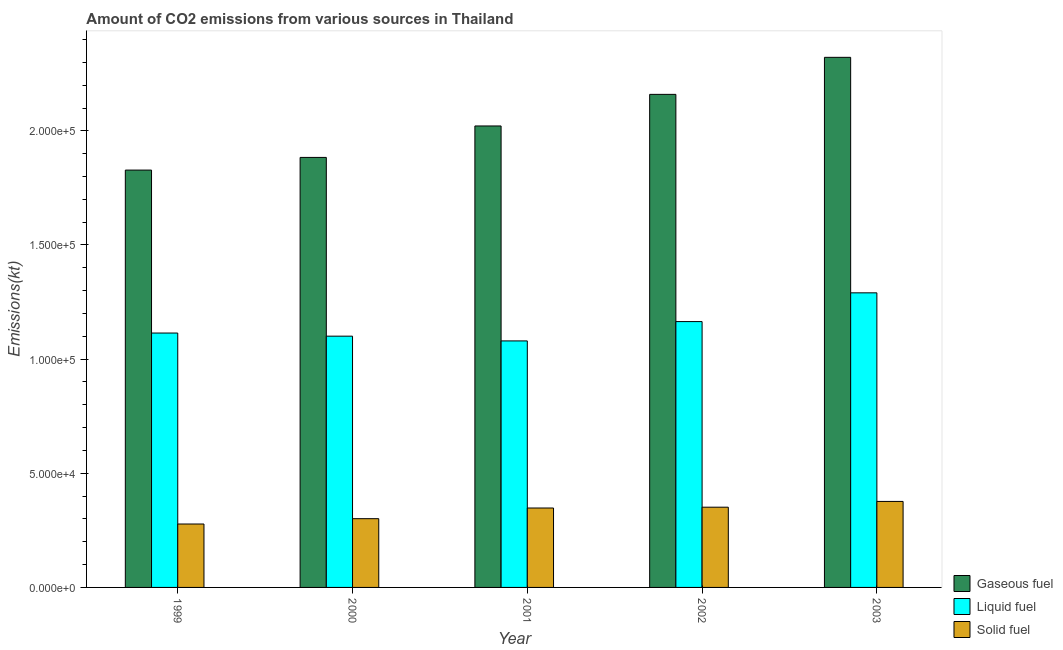Are the number of bars per tick equal to the number of legend labels?
Offer a terse response. Yes. How many bars are there on the 2nd tick from the right?
Keep it short and to the point. 3. What is the amount of co2 emissions from solid fuel in 2000?
Keep it short and to the point. 3.01e+04. Across all years, what is the maximum amount of co2 emissions from gaseous fuel?
Give a very brief answer. 2.32e+05. Across all years, what is the minimum amount of co2 emissions from liquid fuel?
Provide a short and direct response. 1.08e+05. In which year was the amount of co2 emissions from liquid fuel maximum?
Your response must be concise. 2003. What is the total amount of co2 emissions from solid fuel in the graph?
Make the answer very short. 1.65e+05. What is the difference between the amount of co2 emissions from gaseous fuel in 2000 and that in 2002?
Provide a short and direct response. -2.76e+04. What is the difference between the amount of co2 emissions from gaseous fuel in 2000 and the amount of co2 emissions from liquid fuel in 2001?
Give a very brief answer. -1.38e+04. What is the average amount of co2 emissions from gaseous fuel per year?
Offer a terse response. 2.04e+05. What is the ratio of the amount of co2 emissions from gaseous fuel in 2001 to that in 2002?
Your response must be concise. 0.94. Is the amount of co2 emissions from gaseous fuel in 2000 less than that in 2003?
Your answer should be very brief. Yes. What is the difference between the highest and the second highest amount of co2 emissions from gaseous fuel?
Give a very brief answer. 1.62e+04. What is the difference between the highest and the lowest amount of co2 emissions from gaseous fuel?
Your response must be concise. 4.94e+04. What does the 3rd bar from the left in 2000 represents?
Offer a terse response. Solid fuel. What does the 1st bar from the right in 2003 represents?
Provide a short and direct response. Solid fuel. Is it the case that in every year, the sum of the amount of co2 emissions from gaseous fuel and amount of co2 emissions from liquid fuel is greater than the amount of co2 emissions from solid fuel?
Keep it short and to the point. Yes. How many bars are there?
Offer a very short reply. 15. Does the graph contain any zero values?
Provide a short and direct response. No. Does the graph contain grids?
Give a very brief answer. No. Where does the legend appear in the graph?
Your answer should be compact. Bottom right. How many legend labels are there?
Provide a succinct answer. 3. What is the title of the graph?
Offer a terse response. Amount of CO2 emissions from various sources in Thailand. Does "Ages 20-50" appear as one of the legend labels in the graph?
Provide a succinct answer. No. What is the label or title of the Y-axis?
Give a very brief answer. Emissions(kt). What is the Emissions(kt) of Gaseous fuel in 1999?
Give a very brief answer. 1.83e+05. What is the Emissions(kt) in Liquid fuel in 1999?
Your answer should be compact. 1.11e+05. What is the Emissions(kt) in Solid fuel in 1999?
Provide a short and direct response. 2.78e+04. What is the Emissions(kt) in Gaseous fuel in 2000?
Provide a succinct answer. 1.88e+05. What is the Emissions(kt) in Liquid fuel in 2000?
Your answer should be very brief. 1.10e+05. What is the Emissions(kt) of Solid fuel in 2000?
Offer a terse response. 3.01e+04. What is the Emissions(kt) of Gaseous fuel in 2001?
Ensure brevity in your answer.  2.02e+05. What is the Emissions(kt) in Liquid fuel in 2001?
Give a very brief answer. 1.08e+05. What is the Emissions(kt) in Solid fuel in 2001?
Your answer should be compact. 3.48e+04. What is the Emissions(kt) of Gaseous fuel in 2002?
Provide a short and direct response. 2.16e+05. What is the Emissions(kt) in Liquid fuel in 2002?
Offer a terse response. 1.16e+05. What is the Emissions(kt) of Solid fuel in 2002?
Provide a succinct answer. 3.51e+04. What is the Emissions(kt) in Gaseous fuel in 2003?
Provide a short and direct response. 2.32e+05. What is the Emissions(kt) in Liquid fuel in 2003?
Provide a succinct answer. 1.29e+05. What is the Emissions(kt) of Solid fuel in 2003?
Your answer should be very brief. 3.77e+04. Across all years, what is the maximum Emissions(kt) of Gaseous fuel?
Make the answer very short. 2.32e+05. Across all years, what is the maximum Emissions(kt) of Liquid fuel?
Give a very brief answer. 1.29e+05. Across all years, what is the maximum Emissions(kt) of Solid fuel?
Your answer should be compact. 3.77e+04. Across all years, what is the minimum Emissions(kt) of Gaseous fuel?
Your response must be concise. 1.83e+05. Across all years, what is the minimum Emissions(kt) in Liquid fuel?
Your answer should be compact. 1.08e+05. Across all years, what is the minimum Emissions(kt) of Solid fuel?
Your answer should be very brief. 2.78e+04. What is the total Emissions(kt) of Gaseous fuel in the graph?
Your answer should be very brief. 1.02e+06. What is the total Emissions(kt) of Liquid fuel in the graph?
Ensure brevity in your answer.  5.75e+05. What is the total Emissions(kt) in Solid fuel in the graph?
Provide a short and direct response. 1.65e+05. What is the difference between the Emissions(kt) of Gaseous fuel in 1999 and that in 2000?
Your answer should be compact. -5544.5. What is the difference between the Emissions(kt) of Liquid fuel in 1999 and that in 2000?
Your response must be concise. 1371.46. What is the difference between the Emissions(kt) in Solid fuel in 1999 and that in 2000?
Provide a succinct answer. -2328.55. What is the difference between the Emissions(kt) in Gaseous fuel in 1999 and that in 2001?
Your response must be concise. -1.93e+04. What is the difference between the Emissions(kt) in Liquid fuel in 1999 and that in 2001?
Provide a succinct answer. 3446.98. What is the difference between the Emissions(kt) in Solid fuel in 1999 and that in 2001?
Provide a short and direct response. -7007.64. What is the difference between the Emissions(kt) of Gaseous fuel in 1999 and that in 2002?
Offer a terse response. -3.32e+04. What is the difference between the Emissions(kt) in Liquid fuel in 1999 and that in 2002?
Offer a very short reply. -5016.46. What is the difference between the Emissions(kt) in Solid fuel in 1999 and that in 2002?
Make the answer very short. -7363.34. What is the difference between the Emissions(kt) in Gaseous fuel in 1999 and that in 2003?
Make the answer very short. -4.94e+04. What is the difference between the Emissions(kt) in Liquid fuel in 1999 and that in 2003?
Provide a succinct answer. -1.76e+04. What is the difference between the Emissions(kt) of Solid fuel in 1999 and that in 2003?
Give a very brief answer. -9886.23. What is the difference between the Emissions(kt) of Gaseous fuel in 2000 and that in 2001?
Provide a short and direct response. -1.38e+04. What is the difference between the Emissions(kt) in Liquid fuel in 2000 and that in 2001?
Your response must be concise. 2075.52. What is the difference between the Emissions(kt) of Solid fuel in 2000 and that in 2001?
Make the answer very short. -4679.09. What is the difference between the Emissions(kt) of Gaseous fuel in 2000 and that in 2002?
Make the answer very short. -2.76e+04. What is the difference between the Emissions(kt) in Liquid fuel in 2000 and that in 2002?
Offer a very short reply. -6387.91. What is the difference between the Emissions(kt) in Solid fuel in 2000 and that in 2002?
Ensure brevity in your answer.  -5034.79. What is the difference between the Emissions(kt) in Gaseous fuel in 2000 and that in 2003?
Your answer should be very brief. -4.38e+04. What is the difference between the Emissions(kt) in Liquid fuel in 2000 and that in 2003?
Make the answer very short. -1.90e+04. What is the difference between the Emissions(kt) of Solid fuel in 2000 and that in 2003?
Give a very brief answer. -7557.69. What is the difference between the Emissions(kt) of Gaseous fuel in 2001 and that in 2002?
Your answer should be compact. -1.38e+04. What is the difference between the Emissions(kt) in Liquid fuel in 2001 and that in 2002?
Offer a terse response. -8463.44. What is the difference between the Emissions(kt) in Solid fuel in 2001 and that in 2002?
Offer a very short reply. -355.7. What is the difference between the Emissions(kt) in Gaseous fuel in 2001 and that in 2003?
Provide a short and direct response. -3.01e+04. What is the difference between the Emissions(kt) in Liquid fuel in 2001 and that in 2003?
Your answer should be very brief. -2.11e+04. What is the difference between the Emissions(kt) in Solid fuel in 2001 and that in 2003?
Keep it short and to the point. -2878.59. What is the difference between the Emissions(kt) of Gaseous fuel in 2002 and that in 2003?
Ensure brevity in your answer.  -1.62e+04. What is the difference between the Emissions(kt) of Liquid fuel in 2002 and that in 2003?
Make the answer very short. -1.26e+04. What is the difference between the Emissions(kt) in Solid fuel in 2002 and that in 2003?
Offer a terse response. -2522.9. What is the difference between the Emissions(kt) in Gaseous fuel in 1999 and the Emissions(kt) in Liquid fuel in 2000?
Make the answer very short. 7.28e+04. What is the difference between the Emissions(kt) of Gaseous fuel in 1999 and the Emissions(kt) of Solid fuel in 2000?
Your answer should be very brief. 1.53e+05. What is the difference between the Emissions(kt) in Liquid fuel in 1999 and the Emissions(kt) in Solid fuel in 2000?
Keep it short and to the point. 8.13e+04. What is the difference between the Emissions(kt) in Gaseous fuel in 1999 and the Emissions(kt) in Liquid fuel in 2001?
Provide a succinct answer. 7.48e+04. What is the difference between the Emissions(kt) in Gaseous fuel in 1999 and the Emissions(kt) in Solid fuel in 2001?
Provide a short and direct response. 1.48e+05. What is the difference between the Emissions(kt) in Liquid fuel in 1999 and the Emissions(kt) in Solid fuel in 2001?
Provide a succinct answer. 7.66e+04. What is the difference between the Emissions(kt) in Gaseous fuel in 1999 and the Emissions(kt) in Liquid fuel in 2002?
Provide a succinct answer. 6.64e+04. What is the difference between the Emissions(kt) of Gaseous fuel in 1999 and the Emissions(kt) of Solid fuel in 2002?
Provide a short and direct response. 1.48e+05. What is the difference between the Emissions(kt) in Liquid fuel in 1999 and the Emissions(kt) in Solid fuel in 2002?
Your answer should be very brief. 7.63e+04. What is the difference between the Emissions(kt) in Gaseous fuel in 1999 and the Emissions(kt) in Liquid fuel in 2003?
Offer a terse response. 5.38e+04. What is the difference between the Emissions(kt) of Gaseous fuel in 1999 and the Emissions(kt) of Solid fuel in 2003?
Offer a terse response. 1.45e+05. What is the difference between the Emissions(kt) of Liquid fuel in 1999 and the Emissions(kt) of Solid fuel in 2003?
Your answer should be compact. 7.38e+04. What is the difference between the Emissions(kt) in Gaseous fuel in 2000 and the Emissions(kt) in Liquid fuel in 2001?
Your answer should be compact. 8.04e+04. What is the difference between the Emissions(kt) of Gaseous fuel in 2000 and the Emissions(kt) of Solid fuel in 2001?
Your answer should be compact. 1.54e+05. What is the difference between the Emissions(kt) in Liquid fuel in 2000 and the Emissions(kt) in Solid fuel in 2001?
Your response must be concise. 7.53e+04. What is the difference between the Emissions(kt) of Gaseous fuel in 2000 and the Emissions(kt) of Liquid fuel in 2002?
Provide a succinct answer. 7.19e+04. What is the difference between the Emissions(kt) of Gaseous fuel in 2000 and the Emissions(kt) of Solid fuel in 2002?
Your response must be concise. 1.53e+05. What is the difference between the Emissions(kt) in Liquid fuel in 2000 and the Emissions(kt) in Solid fuel in 2002?
Your answer should be very brief. 7.49e+04. What is the difference between the Emissions(kt) of Gaseous fuel in 2000 and the Emissions(kt) of Liquid fuel in 2003?
Keep it short and to the point. 5.93e+04. What is the difference between the Emissions(kt) in Gaseous fuel in 2000 and the Emissions(kt) in Solid fuel in 2003?
Provide a succinct answer. 1.51e+05. What is the difference between the Emissions(kt) of Liquid fuel in 2000 and the Emissions(kt) of Solid fuel in 2003?
Your answer should be very brief. 7.24e+04. What is the difference between the Emissions(kt) of Gaseous fuel in 2001 and the Emissions(kt) of Liquid fuel in 2002?
Your answer should be very brief. 8.57e+04. What is the difference between the Emissions(kt) of Gaseous fuel in 2001 and the Emissions(kt) of Solid fuel in 2002?
Ensure brevity in your answer.  1.67e+05. What is the difference between the Emissions(kt) in Liquid fuel in 2001 and the Emissions(kt) in Solid fuel in 2002?
Your answer should be very brief. 7.28e+04. What is the difference between the Emissions(kt) in Gaseous fuel in 2001 and the Emissions(kt) in Liquid fuel in 2003?
Offer a terse response. 7.31e+04. What is the difference between the Emissions(kt) of Gaseous fuel in 2001 and the Emissions(kt) of Solid fuel in 2003?
Your answer should be very brief. 1.64e+05. What is the difference between the Emissions(kt) in Liquid fuel in 2001 and the Emissions(kt) in Solid fuel in 2003?
Give a very brief answer. 7.03e+04. What is the difference between the Emissions(kt) of Gaseous fuel in 2002 and the Emissions(kt) of Liquid fuel in 2003?
Offer a terse response. 8.69e+04. What is the difference between the Emissions(kt) in Gaseous fuel in 2002 and the Emissions(kt) in Solid fuel in 2003?
Make the answer very short. 1.78e+05. What is the difference between the Emissions(kt) of Liquid fuel in 2002 and the Emissions(kt) of Solid fuel in 2003?
Provide a short and direct response. 7.88e+04. What is the average Emissions(kt) in Gaseous fuel per year?
Ensure brevity in your answer.  2.04e+05. What is the average Emissions(kt) in Liquid fuel per year?
Provide a succinct answer. 1.15e+05. What is the average Emissions(kt) in Solid fuel per year?
Offer a terse response. 3.31e+04. In the year 1999, what is the difference between the Emissions(kt) of Gaseous fuel and Emissions(kt) of Liquid fuel?
Your response must be concise. 7.14e+04. In the year 1999, what is the difference between the Emissions(kt) in Gaseous fuel and Emissions(kt) in Solid fuel?
Your answer should be compact. 1.55e+05. In the year 1999, what is the difference between the Emissions(kt) of Liquid fuel and Emissions(kt) of Solid fuel?
Your answer should be compact. 8.36e+04. In the year 2000, what is the difference between the Emissions(kt) of Gaseous fuel and Emissions(kt) of Liquid fuel?
Your answer should be compact. 7.83e+04. In the year 2000, what is the difference between the Emissions(kt) of Gaseous fuel and Emissions(kt) of Solid fuel?
Offer a very short reply. 1.58e+05. In the year 2000, what is the difference between the Emissions(kt) in Liquid fuel and Emissions(kt) in Solid fuel?
Give a very brief answer. 7.99e+04. In the year 2001, what is the difference between the Emissions(kt) of Gaseous fuel and Emissions(kt) of Liquid fuel?
Ensure brevity in your answer.  9.42e+04. In the year 2001, what is the difference between the Emissions(kt) in Gaseous fuel and Emissions(kt) in Solid fuel?
Provide a succinct answer. 1.67e+05. In the year 2001, what is the difference between the Emissions(kt) of Liquid fuel and Emissions(kt) of Solid fuel?
Ensure brevity in your answer.  7.32e+04. In the year 2002, what is the difference between the Emissions(kt) of Gaseous fuel and Emissions(kt) of Liquid fuel?
Your response must be concise. 9.95e+04. In the year 2002, what is the difference between the Emissions(kt) in Gaseous fuel and Emissions(kt) in Solid fuel?
Provide a succinct answer. 1.81e+05. In the year 2002, what is the difference between the Emissions(kt) of Liquid fuel and Emissions(kt) of Solid fuel?
Provide a succinct answer. 8.13e+04. In the year 2003, what is the difference between the Emissions(kt) of Gaseous fuel and Emissions(kt) of Liquid fuel?
Provide a short and direct response. 1.03e+05. In the year 2003, what is the difference between the Emissions(kt) in Gaseous fuel and Emissions(kt) in Solid fuel?
Offer a very short reply. 1.95e+05. In the year 2003, what is the difference between the Emissions(kt) in Liquid fuel and Emissions(kt) in Solid fuel?
Give a very brief answer. 9.14e+04. What is the ratio of the Emissions(kt) in Gaseous fuel in 1999 to that in 2000?
Offer a terse response. 0.97. What is the ratio of the Emissions(kt) in Liquid fuel in 1999 to that in 2000?
Offer a very short reply. 1.01. What is the ratio of the Emissions(kt) in Solid fuel in 1999 to that in 2000?
Your response must be concise. 0.92. What is the ratio of the Emissions(kt) in Gaseous fuel in 1999 to that in 2001?
Offer a very short reply. 0.9. What is the ratio of the Emissions(kt) of Liquid fuel in 1999 to that in 2001?
Your answer should be very brief. 1.03. What is the ratio of the Emissions(kt) of Solid fuel in 1999 to that in 2001?
Your response must be concise. 0.8. What is the ratio of the Emissions(kt) of Gaseous fuel in 1999 to that in 2002?
Offer a terse response. 0.85. What is the ratio of the Emissions(kt) of Liquid fuel in 1999 to that in 2002?
Provide a succinct answer. 0.96. What is the ratio of the Emissions(kt) of Solid fuel in 1999 to that in 2002?
Make the answer very short. 0.79. What is the ratio of the Emissions(kt) of Gaseous fuel in 1999 to that in 2003?
Offer a very short reply. 0.79. What is the ratio of the Emissions(kt) of Liquid fuel in 1999 to that in 2003?
Provide a succinct answer. 0.86. What is the ratio of the Emissions(kt) in Solid fuel in 1999 to that in 2003?
Give a very brief answer. 0.74. What is the ratio of the Emissions(kt) of Gaseous fuel in 2000 to that in 2001?
Your answer should be compact. 0.93. What is the ratio of the Emissions(kt) of Liquid fuel in 2000 to that in 2001?
Offer a very short reply. 1.02. What is the ratio of the Emissions(kt) in Solid fuel in 2000 to that in 2001?
Ensure brevity in your answer.  0.87. What is the ratio of the Emissions(kt) in Gaseous fuel in 2000 to that in 2002?
Your answer should be very brief. 0.87. What is the ratio of the Emissions(kt) in Liquid fuel in 2000 to that in 2002?
Make the answer very short. 0.95. What is the ratio of the Emissions(kt) in Solid fuel in 2000 to that in 2002?
Give a very brief answer. 0.86. What is the ratio of the Emissions(kt) in Gaseous fuel in 2000 to that in 2003?
Your answer should be compact. 0.81. What is the ratio of the Emissions(kt) of Liquid fuel in 2000 to that in 2003?
Provide a short and direct response. 0.85. What is the ratio of the Emissions(kt) of Solid fuel in 2000 to that in 2003?
Your answer should be compact. 0.8. What is the ratio of the Emissions(kt) of Gaseous fuel in 2001 to that in 2002?
Your answer should be compact. 0.94. What is the ratio of the Emissions(kt) of Liquid fuel in 2001 to that in 2002?
Offer a terse response. 0.93. What is the ratio of the Emissions(kt) in Gaseous fuel in 2001 to that in 2003?
Keep it short and to the point. 0.87. What is the ratio of the Emissions(kt) in Liquid fuel in 2001 to that in 2003?
Ensure brevity in your answer.  0.84. What is the ratio of the Emissions(kt) of Solid fuel in 2001 to that in 2003?
Your answer should be very brief. 0.92. What is the ratio of the Emissions(kt) in Gaseous fuel in 2002 to that in 2003?
Your answer should be compact. 0.93. What is the ratio of the Emissions(kt) in Liquid fuel in 2002 to that in 2003?
Give a very brief answer. 0.9. What is the ratio of the Emissions(kt) in Solid fuel in 2002 to that in 2003?
Keep it short and to the point. 0.93. What is the difference between the highest and the second highest Emissions(kt) of Gaseous fuel?
Your answer should be compact. 1.62e+04. What is the difference between the highest and the second highest Emissions(kt) in Liquid fuel?
Make the answer very short. 1.26e+04. What is the difference between the highest and the second highest Emissions(kt) in Solid fuel?
Offer a very short reply. 2522.9. What is the difference between the highest and the lowest Emissions(kt) of Gaseous fuel?
Make the answer very short. 4.94e+04. What is the difference between the highest and the lowest Emissions(kt) in Liquid fuel?
Make the answer very short. 2.11e+04. What is the difference between the highest and the lowest Emissions(kt) of Solid fuel?
Provide a short and direct response. 9886.23. 